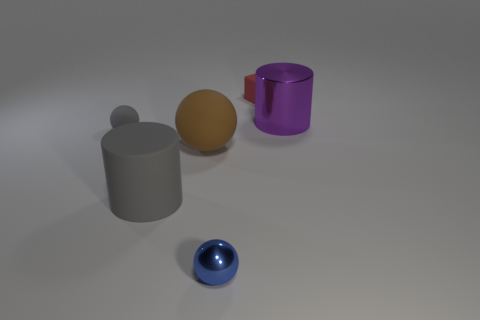There is a gray thing that is the same size as the red thing; what shape is it?
Make the answer very short. Sphere. There is a tiny matte thing to the left of the red cube that is behind the metallic thing in front of the large metal cylinder; what is its color?
Your response must be concise. Gray. How many things are either small rubber objects that are to the left of the tiny cube or small green cylinders?
Offer a very short reply. 1. What is the material of the gray object that is the same size as the red rubber block?
Offer a very short reply. Rubber. The cylinder that is in front of the gray thing behind the gray rubber thing that is in front of the gray rubber sphere is made of what material?
Provide a short and direct response. Rubber. The tiny block is what color?
Your answer should be compact. Red. How many big things are either red rubber objects or cyan metal blocks?
Your answer should be very brief. 0. Does the large cylinder in front of the purple thing have the same material as the tiny block behind the brown sphere?
Keep it short and to the point. Yes. Are any cylinders visible?
Your answer should be compact. Yes. Are there more large brown rubber objects on the left side of the tiny blue ball than big balls that are to the left of the brown sphere?
Offer a terse response. Yes. 